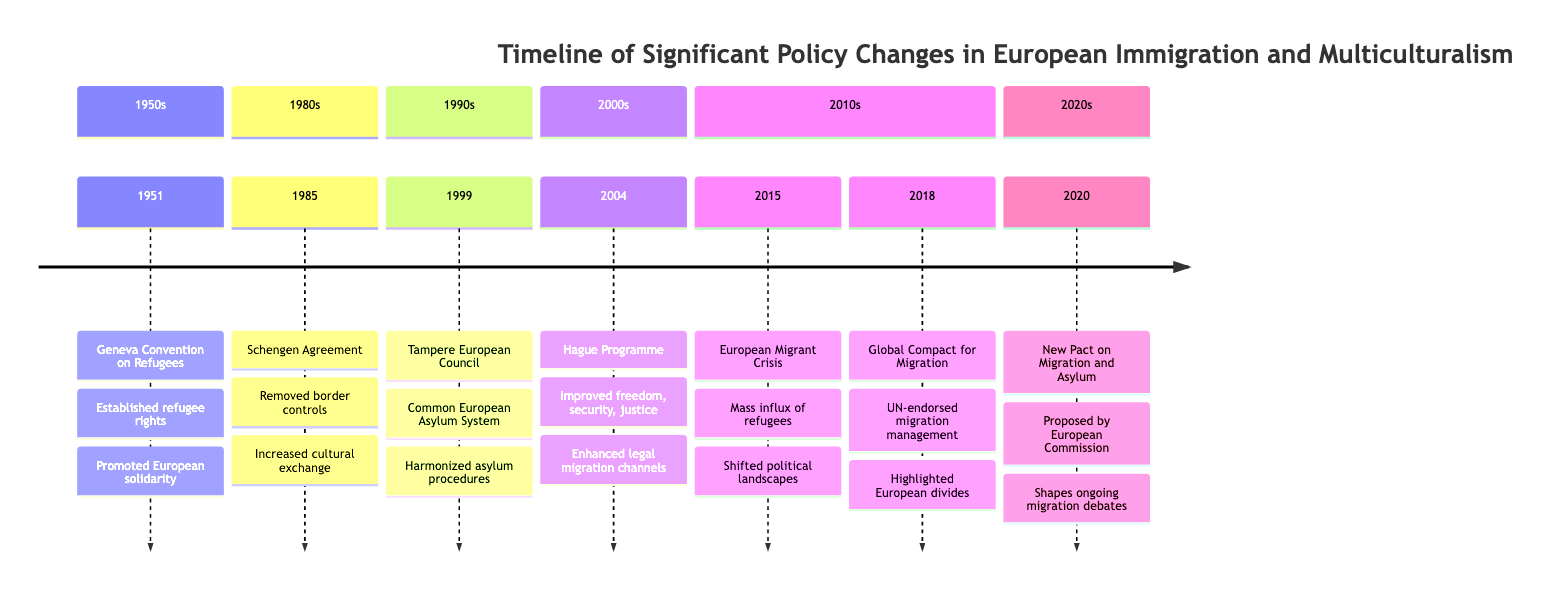What year was the Geneva Convention on Refugees enacted? According to the timeline, the Geneva Convention on Refugees was established in 1951.
Answer: 1951 What significant event happened in 1985? The timeline indicates that the Schengen Agreement was the significant event in 1985.
Answer: Schengen Agreement What was a public response to the 2015 European Migrant Crisis? The timeline describes the public response to the 2015 European Migrant Crisis as polarized, highlighting divisions in opinions about humanitarian aid versus anti-immigration sentiments.
Answer: Polarized How many key events are listed in the timeline? By counting the individual events from the timeline, there are a total of 7 key events listed.
Answer: 7 Which event initiated the creation of a Common European Asylum System? According to the timeline, the event that initiated the creation of a Common European Asylum System was the Tampere European Council in 1999.
Answer: Tampere European Council What social impact is associated with the Hague Programme? The timeline specifies that the Hague Programme enhanced security and justice systems, promoting legal migration and integration policies.
Answer: Enhanced security and justice systems What was one outcome of the 2018 Global Compact for Migration? The timeline notes that the Global Compact highlighted divides within Europe over migration policies; this represents a significant outcome of the event.
Answer: Highlighted divides within Europe What was a public response to the New Pact on Migration and Asylum proposed in 2020? The timeline indicates that the public response to the New Pact on Migration and Asylum was mixed, with some praising its aims and others criticizing its comprehensiveness.
Answer: Mixed Which decade did the Geneva Convention on Refugees occur? The timeline clearly places the Geneva Convention on Refugees in the 1950s.
Answer: 1950s 